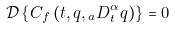Convert formula to latex. <formula><loc_0><loc_0><loc_500><loc_500>\mathcal { D } \left \{ { C } _ { f } \left ( t , q , { _ { a } D _ { t } ^ { \alpha } q } \right ) \right \} = 0</formula> 